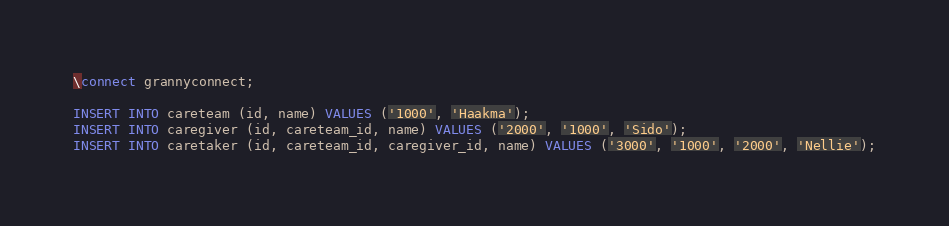<code> <loc_0><loc_0><loc_500><loc_500><_SQL_>\connect grannyconnect;

INSERT INTO careteam (id, name) VALUES ('1000', 'Haakma');
INSERT INTO caregiver (id, careteam_id, name) VALUES ('2000', '1000', 'Sido');
INSERT INTO caretaker (id, careteam_id, caregiver_id, name) VALUES ('3000', '1000', '2000', 'Nellie');

</code> 